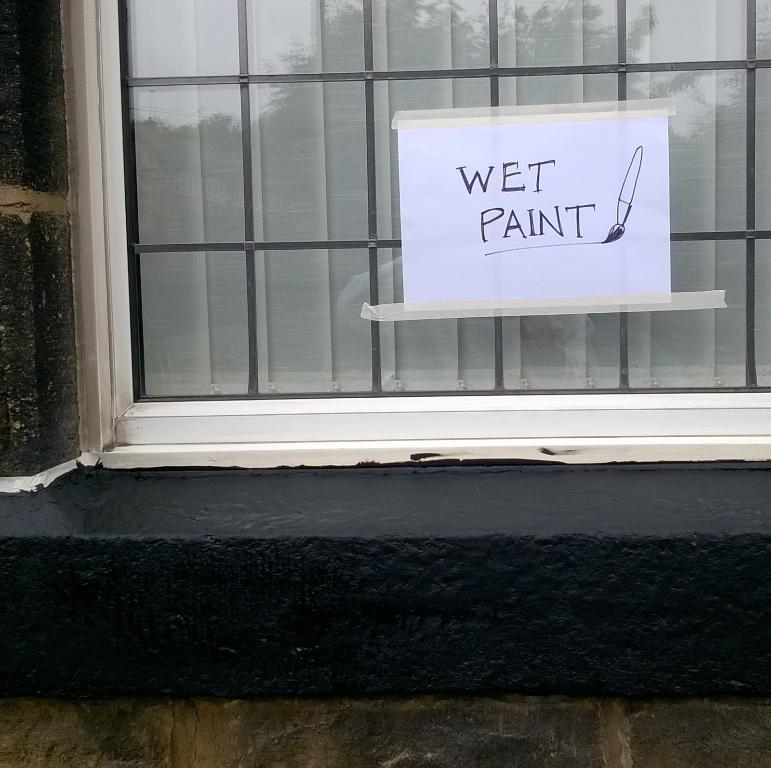What can be seen in the image that allows light to enter a room? There is a window in the image that allows light to enter a room. What is covering the window in the image? The window has a curtain. What is written or drawn on the paper in the image? There is a paper with text in the image. What is the background of the image made of? There is a wall in the image. What type of bushes can be seen growing near the wall in the image? There are no bushes present in the image; it only features a window, a curtain, a paper with text, and a wall. How comfortable is the chair in the image? There is no chair present in the image, so it is not possible to determine its comfort level. 